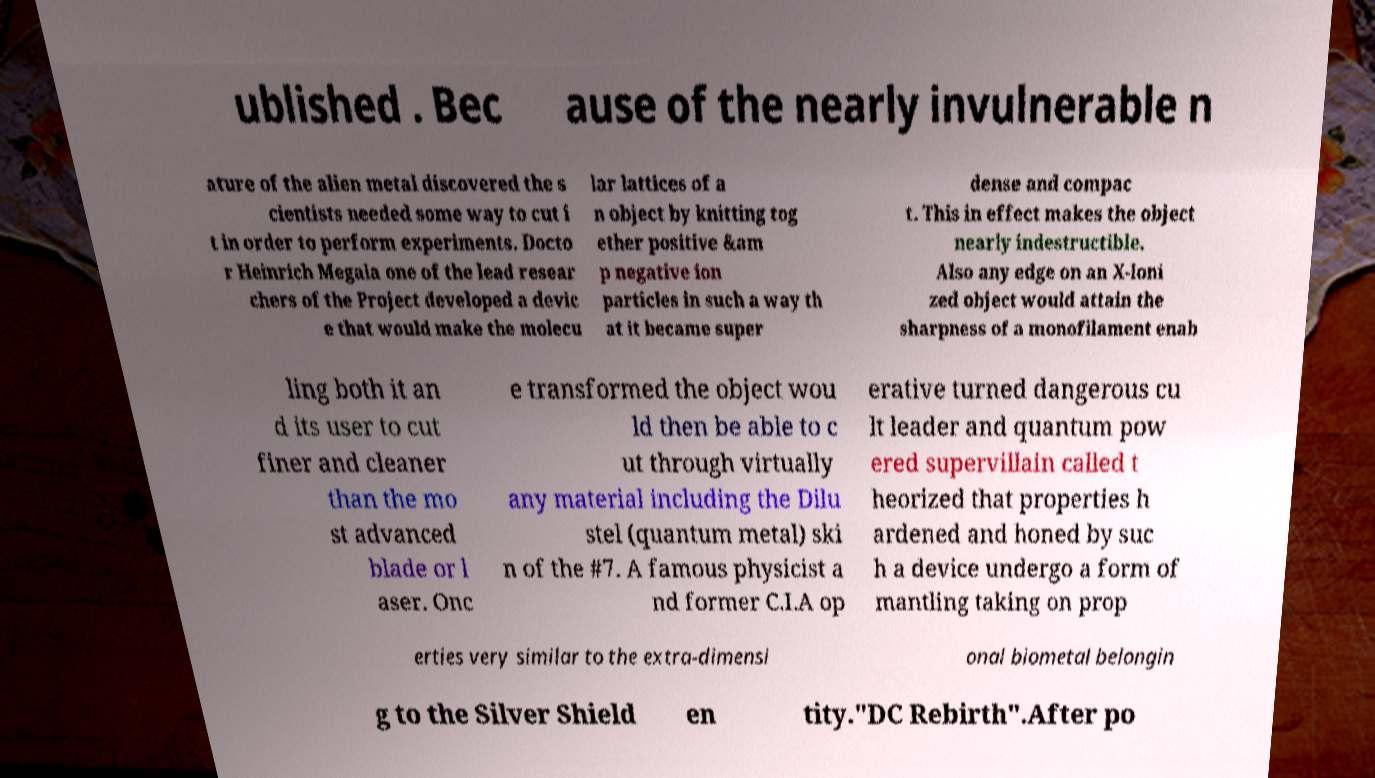Can you accurately transcribe the text from the provided image for me? ublished . Bec ause of the nearly invulnerable n ature of the alien metal discovered the s cientists needed some way to cut i t in order to perform experiments. Docto r Heinrich Megala one of the lead resear chers of the Project developed a devic e that would make the molecu lar lattices of a n object by knitting tog ether positive &am p negative ion particles in such a way th at it became super dense and compac t. This in effect makes the object nearly indestructible. Also any edge on an X-Ioni zed object would attain the sharpness of a monofilament enab ling both it an d its user to cut finer and cleaner than the mo st advanced blade or l aser. Onc e transformed the object wou ld then be able to c ut through virtually any material including the Dilu stel (quantum metal) ski n of the #7. A famous physicist a nd former C.I.A op erative turned dangerous cu lt leader and quantum pow ered supervillain called t heorized that properties h ardened and honed by suc h a device undergo a form of mantling taking on prop erties very similar to the extra-dimensi onal biometal belongin g to the Silver Shield en tity."DC Rebirth".After po 